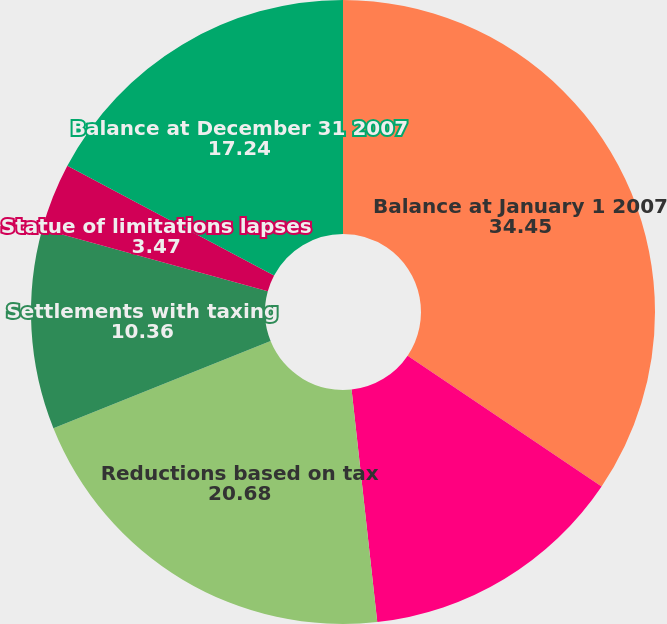Convert chart. <chart><loc_0><loc_0><loc_500><loc_500><pie_chart><fcel>Balance at January 1 2007<fcel>Additions based on tax<fcel>Reductions based on tax<fcel>Settlements with taxing<fcel>Statue of limitations lapses<fcel>Balance at December 31 2007<nl><fcel>34.45%<fcel>13.8%<fcel>20.68%<fcel>10.36%<fcel>3.47%<fcel>17.24%<nl></chart> 